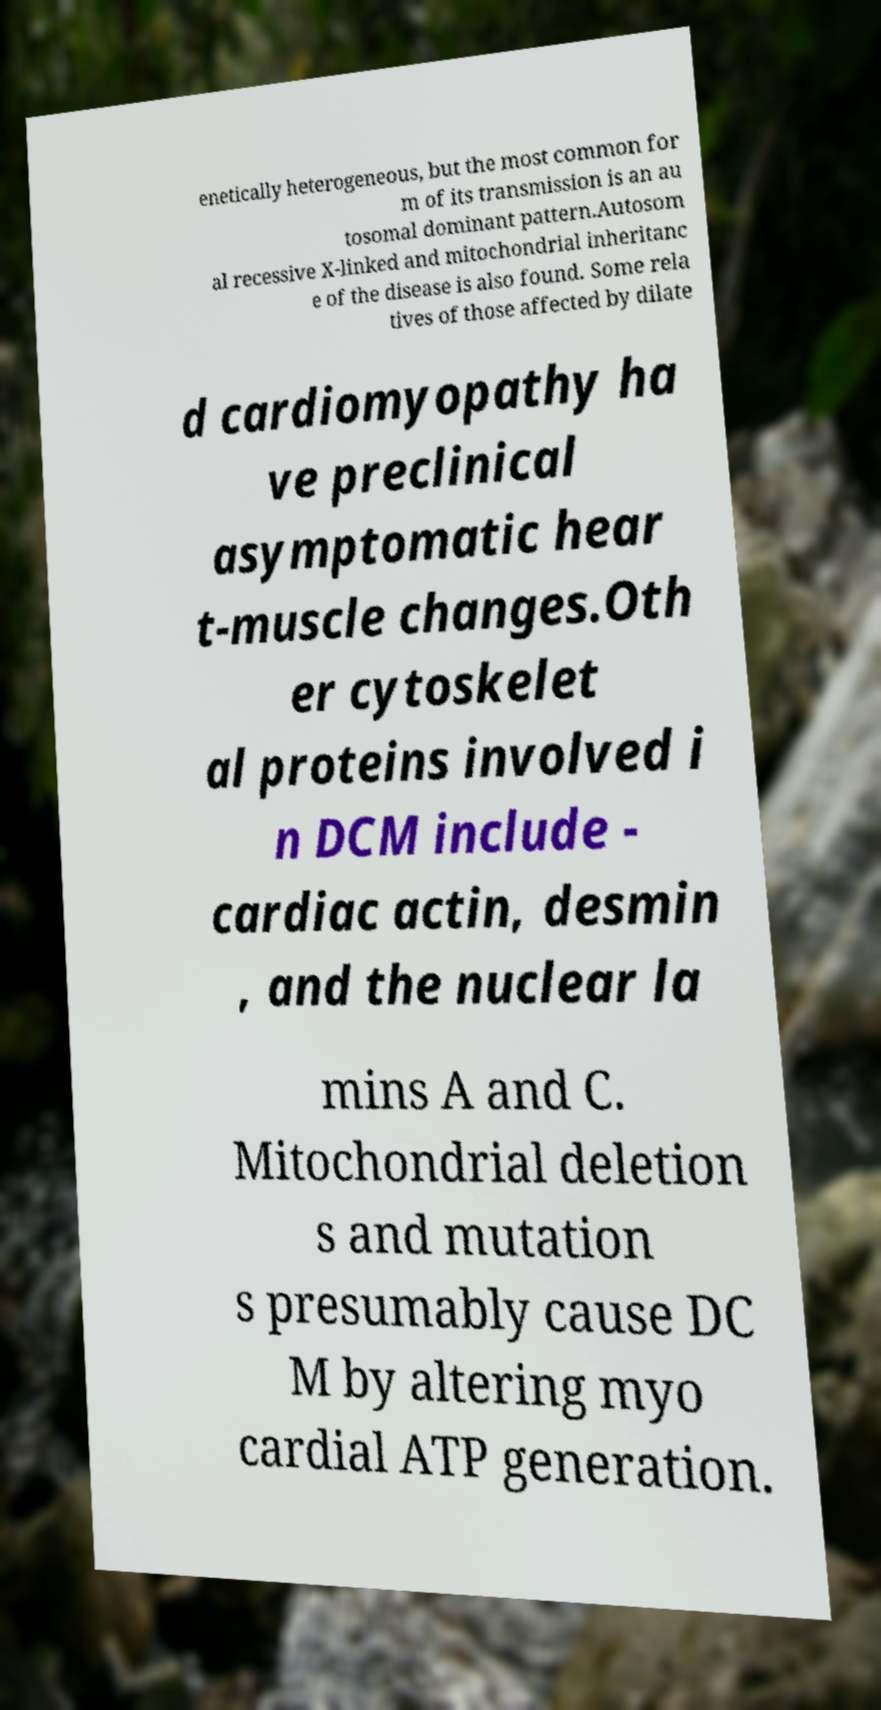Could you assist in decoding the text presented in this image and type it out clearly? enetically heterogeneous, but the most common for m of its transmission is an au tosomal dominant pattern.Autosom al recessive X-linked and mitochondrial inheritanc e of the disease is also found. Some rela tives of those affected by dilate d cardiomyopathy ha ve preclinical asymptomatic hear t-muscle changes.Oth er cytoskelet al proteins involved i n DCM include - cardiac actin, desmin , and the nuclear la mins A and C. Mitochondrial deletion s and mutation s presumably cause DC M by altering myo cardial ATP generation. 